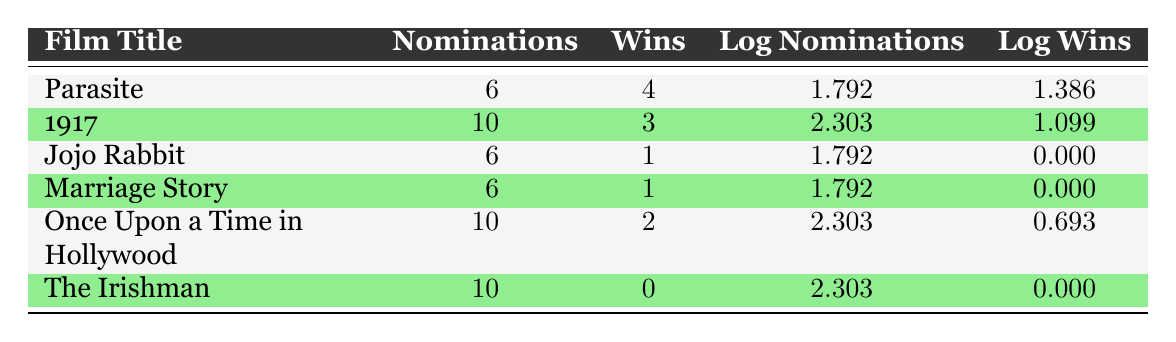What film won the most awards? "Parasite" has the highest wins with 4, while the others have fewer wins. Therefore, Parasite is the film that won the most awards.
Answer: Parasite How many nominations does "1917" have? The table shows that "1917" has 10 nominations listed directly under the nominations column.
Answer: 10 What is the average number of wins for the films listed? The films collectively have a total of (4 + 3 + 1 + 1 + 2 + 0) = 11 wins. There are 6 films, so the average is 11/6 = 1.83.
Answer: 1.83 Is it true that "The Irishman" has any wins? "The Irishman" is listed with 0 wins in the table, indicating that it did not win any awards.
Answer: No Which film has the highest logarithmic value for wins? Reviewing the log wins column, "Parasite" has the highest value of 1.386, which is greater than the others.
Answer: Parasite How many more nominations does "Once Upon a Time in Hollywood" have compared to "Jojo Rabbit"? "Once Upon a Time in Hollywood" has 10 nominations while "Jojo Rabbit" has 6. The difference is 10 - 6 = 4 nominations.
Answer: 4 What is the total of logarithmic values for nominations across all films? The total of the log nominations is calculated as 1.792 + 2.303 + 1.792 + 1.792 + 2.303 + 2.303 = 12.585.
Answer: 12.585 Does "Marriage Story" have more wins than "Jojo Rabbit"? "Marriage Story" has 1 win while "Jojo Rabbit" also has 1 win. Therefore, they are equal and Marriage Story does not have more wins.
Answer: No What is the difference in logarithmic values for nominations between "Parasite" and "The Irishman"? The log nominations for "Parasite" is 1.792 and for "The Irishman" is 2.303. The difference is 2.303 - 1.792 = 0.511.
Answer: 0.511 